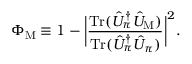Convert formula to latex. <formula><loc_0><loc_0><loc_500><loc_500>\Phi _ { M } \equiv 1 - \left | \frac { T r ( \hat { U } _ { \pi } ^ { \dagger } \hat { U } _ { M } ) } { T r ( \hat { U } _ { \pi } ^ { \dagger } \hat { U } _ { \pi } ) } \right | ^ { 2 } .</formula> 